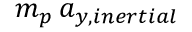<formula> <loc_0><loc_0><loc_500><loc_500>m _ { p } \, a _ { y , i n e r t i a l }</formula> 